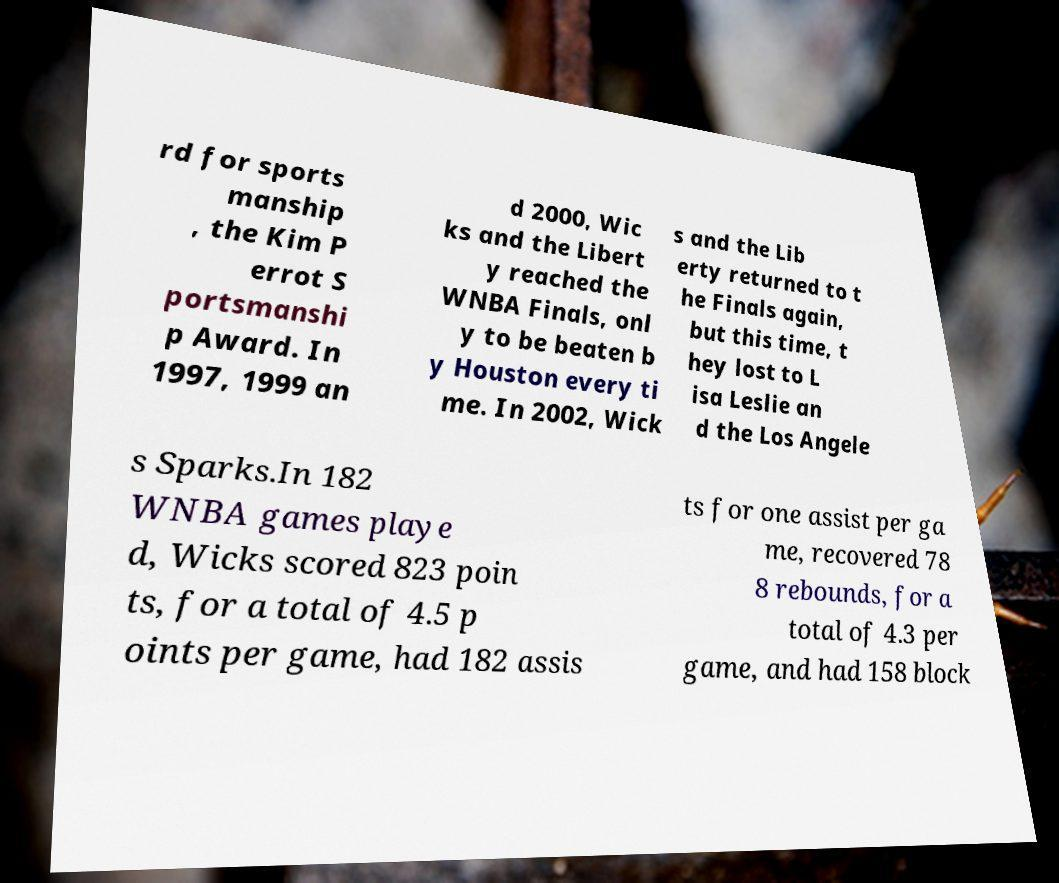I need the written content from this picture converted into text. Can you do that? rd for sports manship , the Kim P errot S portsmanshi p Award. In 1997, 1999 an d 2000, Wic ks and the Libert y reached the WNBA Finals, onl y to be beaten b y Houston every ti me. In 2002, Wick s and the Lib erty returned to t he Finals again, but this time, t hey lost to L isa Leslie an d the Los Angele s Sparks.In 182 WNBA games playe d, Wicks scored 823 poin ts, for a total of 4.5 p oints per game, had 182 assis ts for one assist per ga me, recovered 78 8 rebounds, for a total of 4.3 per game, and had 158 block 